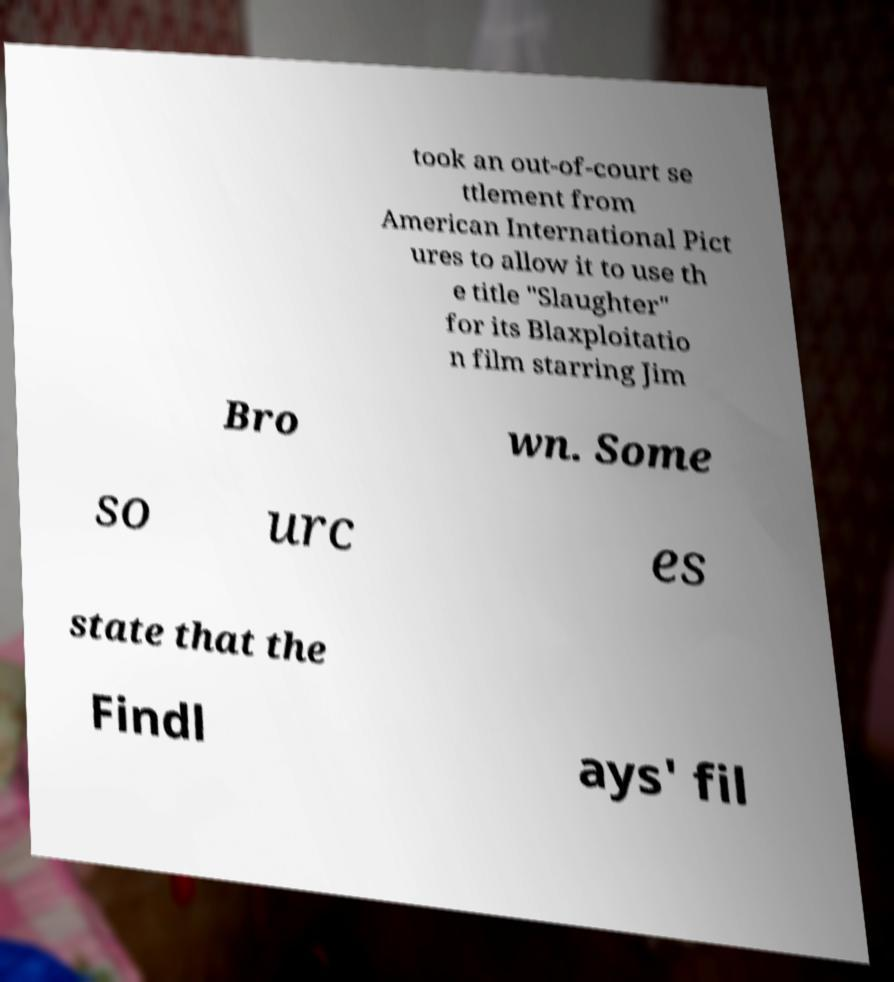Could you extract and type out the text from this image? took an out-of-court se ttlement from American International Pict ures to allow it to use th e title "Slaughter" for its Blaxploitatio n film starring Jim Bro wn. Some so urc es state that the Findl ays' fil 